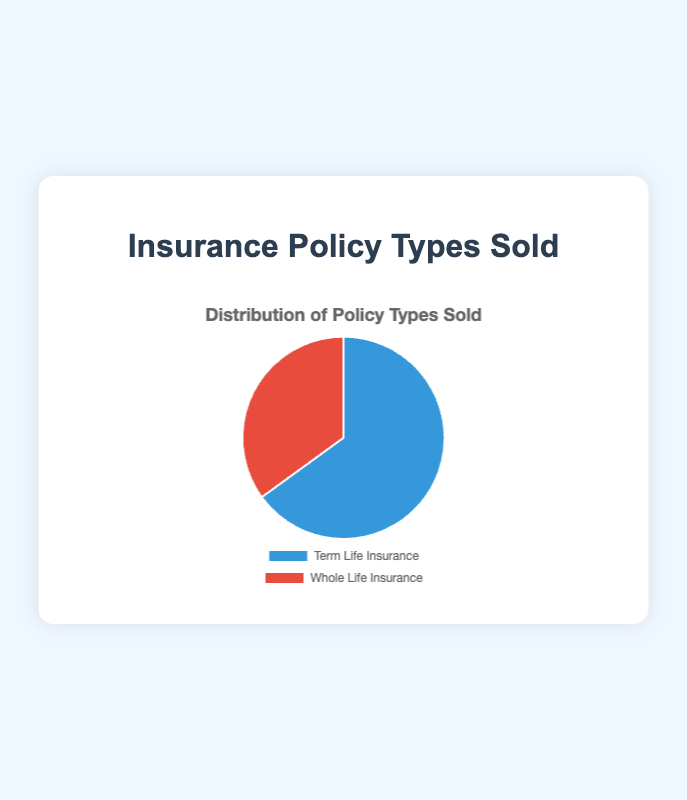what percentage of insurance policies sold is for term life insurance? The pie chart labels show that term life insurance policies are 65% of the total sold.
Answer: 65% what percentage of insurance policies sold is for whole life insurance? The pie chart labels show that whole life insurance policies are 35% of the total sold.
Answer: 35% Which type of insurance policy is sold more, term life insurance or whole life insurance? By comparing the percentages, term life insurance (65%) is more than whole life insurance (35%).
Answer: term life insurance How much more popular is term life insurance compared to whole life insurance? Subtract the percentage of whole life insurance (35%) from term life insurance (65%). \(65\% - 35\% = 30\%\)
Answer: 30% What is the total percentage of insurance policies sold? Adding the percentages of both term life (65%) and whole life (35%) insurance policies gives \(65\% + 35\% = 100\%\).
Answer: 100% If 100 policies were sold, how many would be term life insurance policies? Assuming 100 policies are sold, 65% of them would be term life insurance. \(65\% \times 100\% = 65\)
Answer: 65 If 100 policies were sold, how many would be whole life insurance policies? Assuming 100 policies are sold, 35% of them would be whole life insurance. \(35\% \times 100\% = 35\)
Answer: 35 What color is used to represent term life insurance in the chart? The pie chart segment for term life insurance is represented in blue.
Answer: blue What color is used to represent whole life insurance in the chart? The pie chart segment for whole life insurance is represented in red.
Answer: red 